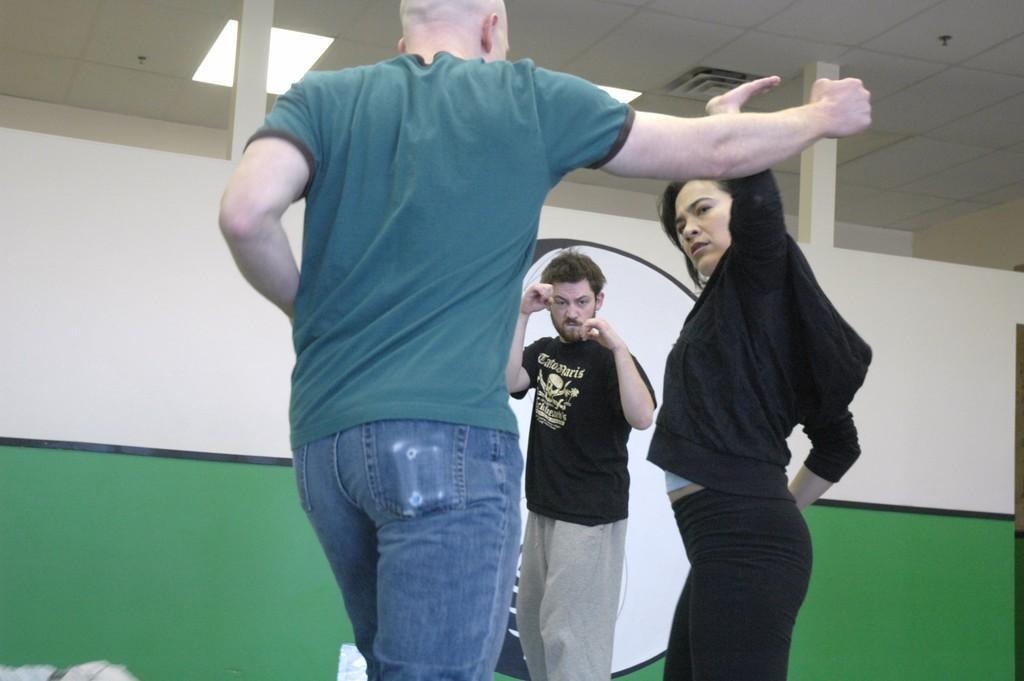In one or two sentences, can you explain what this image depicts? In this image three persons are standing. Behind them there is a wall. Top of the image few lights are attached to the roof. 